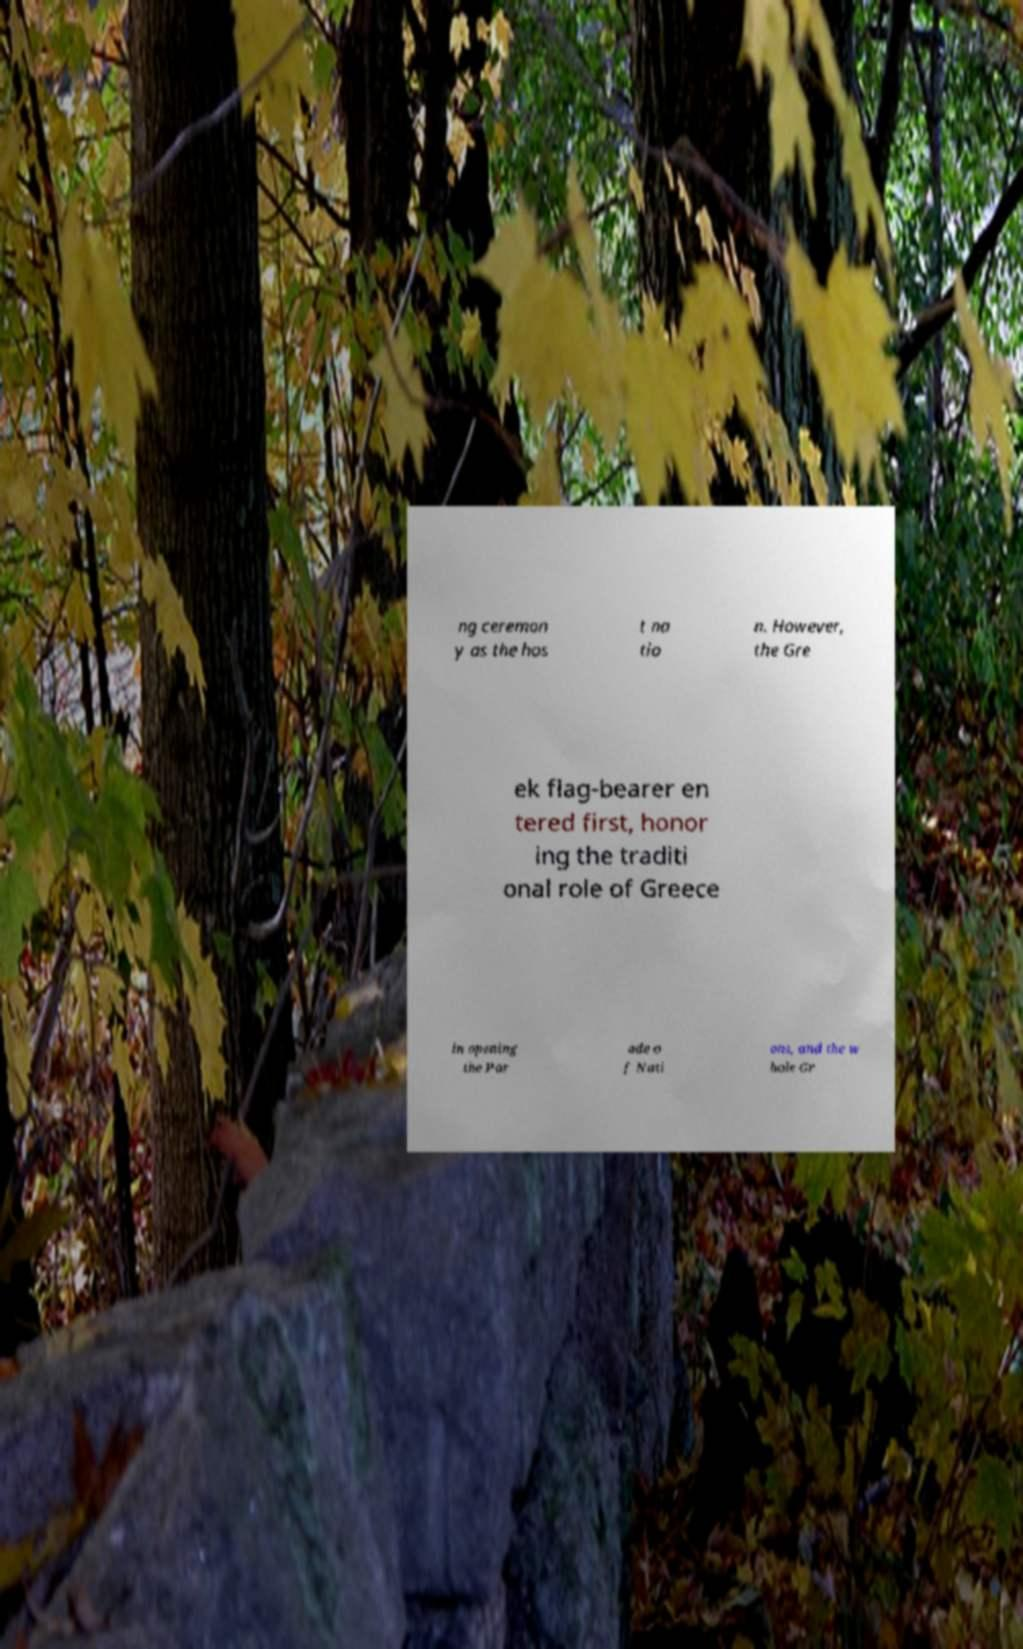Can you read and provide the text displayed in the image?This photo seems to have some interesting text. Can you extract and type it out for me? ng ceremon y as the hos t na tio n. However, the Gre ek flag-bearer en tered first, honor ing the traditi onal role of Greece in opening the Par ade o f Nati ons, and the w hole Gr 